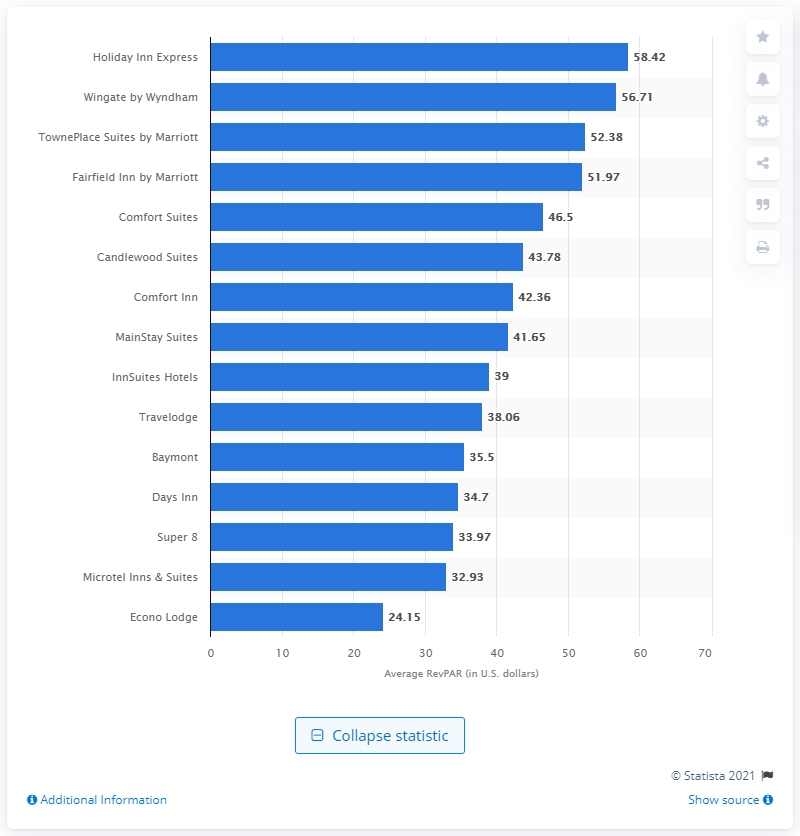Indicate a few pertinent items in this graphic. The average revenue per available room of the Comfort Inn chain in 2009 was $42.36. 